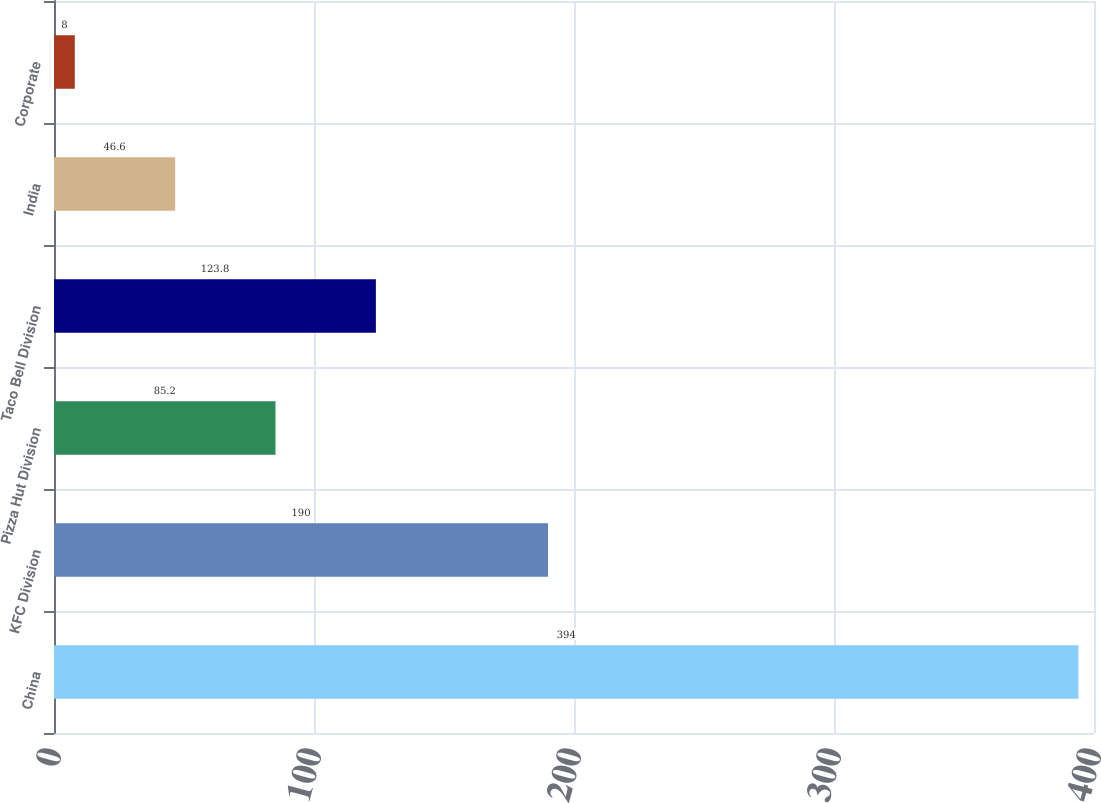<chart> <loc_0><loc_0><loc_500><loc_500><bar_chart><fcel>China<fcel>KFC Division<fcel>Pizza Hut Division<fcel>Taco Bell Division<fcel>India<fcel>Corporate<nl><fcel>394<fcel>190<fcel>85.2<fcel>123.8<fcel>46.6<fcel>8<nl></chart> 